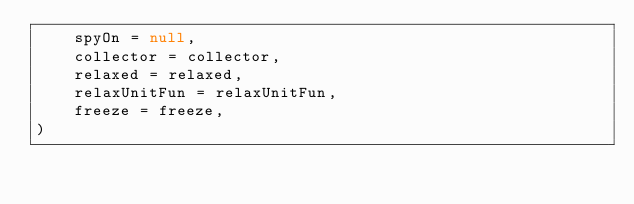Convert code to text. <code><loc_0><loc_0><loc_500><loc_500><_Kotlin_>    spyOn = null,
    collector = collector,
    relaxed = relaxed,
    relaxUnitFun = relaxUnitFun,
    freeze = freeze,
)
</code> 